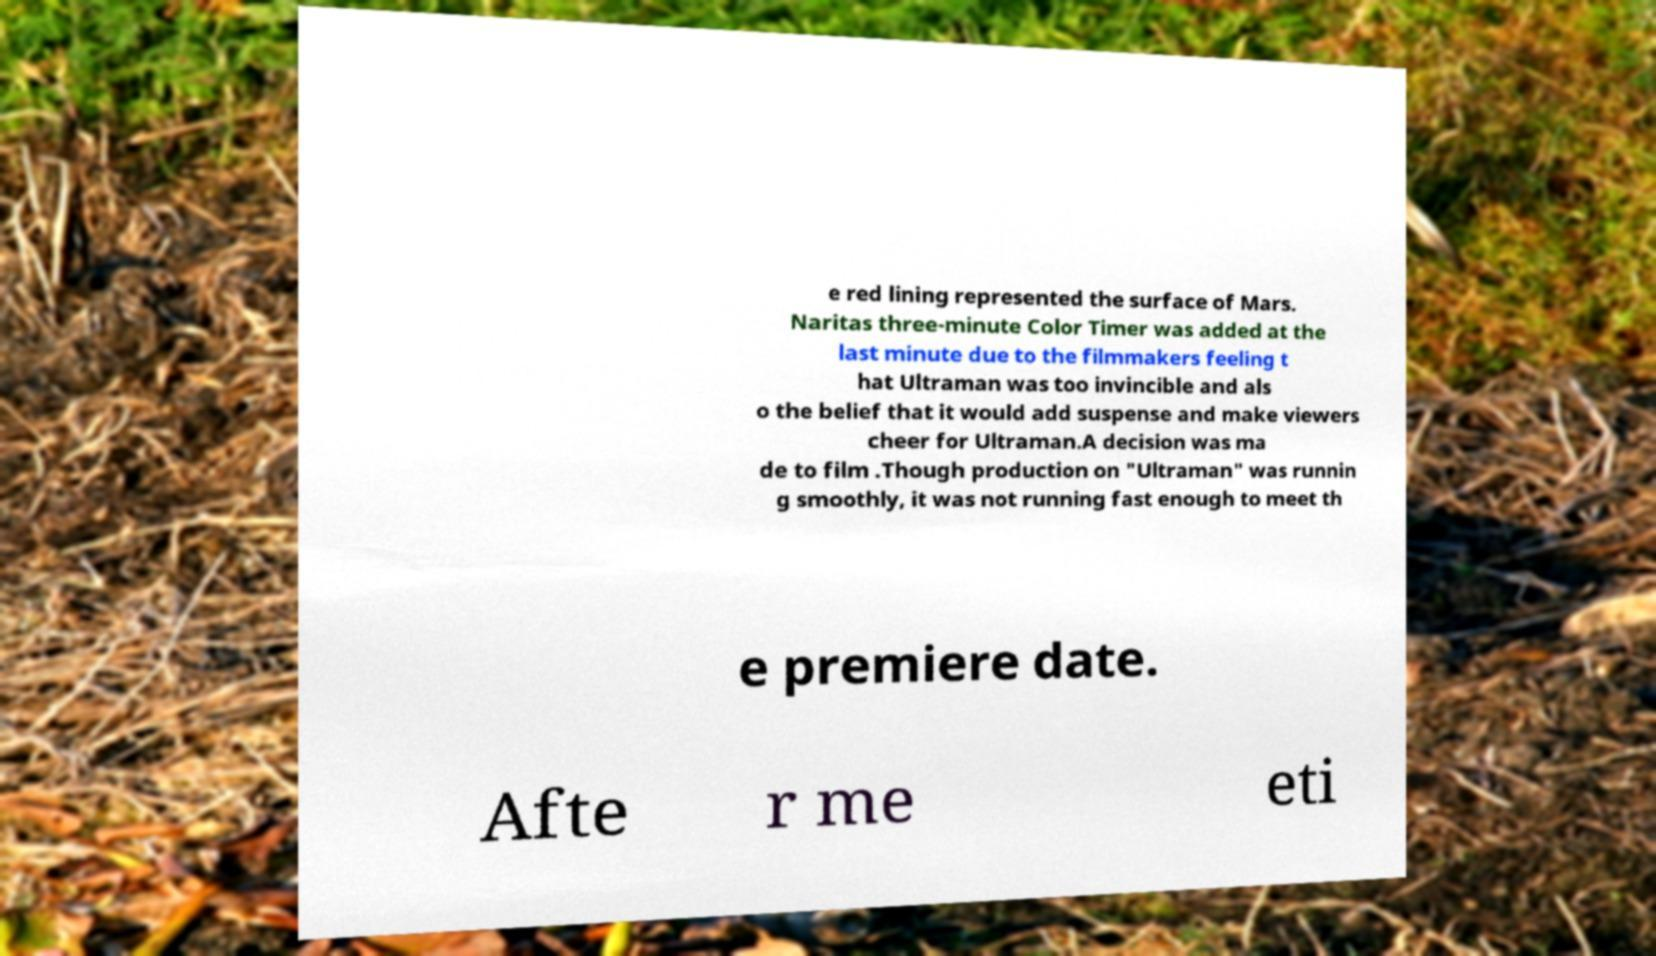Could you assist in decoding the text presented in this image and type it out clearly? e red lining represented the surface of Mars. Naritas three-minute Color Timer was added at the last minute due to the filmmakers feeling t hat Ultraman was too invincible and als o the belief that it would add suspense and make viewers cheer for Ultraman.A decision was ma de to film .Though production on "Ultraman" was runnin g smoothly, it was not running fast enough to meet th e premiere date. Afte r me eti 